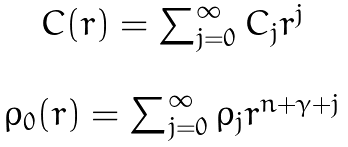Convert formula to latex. <formula><loc_0><loc_0><loc_500><loc_500>\begin{array} { c } C ( r ) = \sum _ { j = 0 } ^ { \infty } C _ { j } r ^ { j } \\ \\ \rho _ { 0 } ( r ) = \sum _ { j = 0 } ^ { \infty } \rho _ { j } r ^ { n + \gamma + j } \\ \\ \end{array}</formula> 